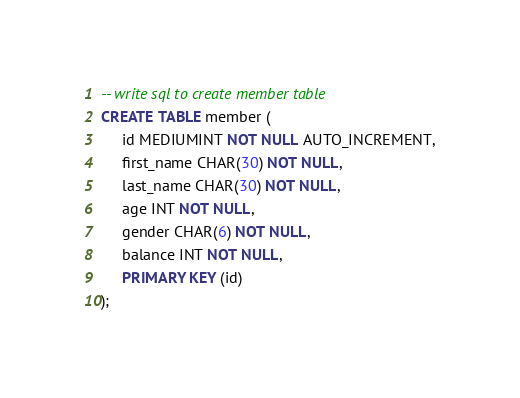<code> <loc_0><loc_0><loc_500><loc_500><_SQL_>-- write sql to create member table
CREATE TABLE member (
     id MEDIUMINT NOT NULL AUTO_INCREMENT,
     first_name CHAR(30) NOT NULL,
     last_name CHAR(30) NOT NULL,
     age INT NOT NULL,
     gender CHAR(6) NOT NULL,
     balance INT NOT NULL,
     PRIMARY KEY (id)
);</code> 